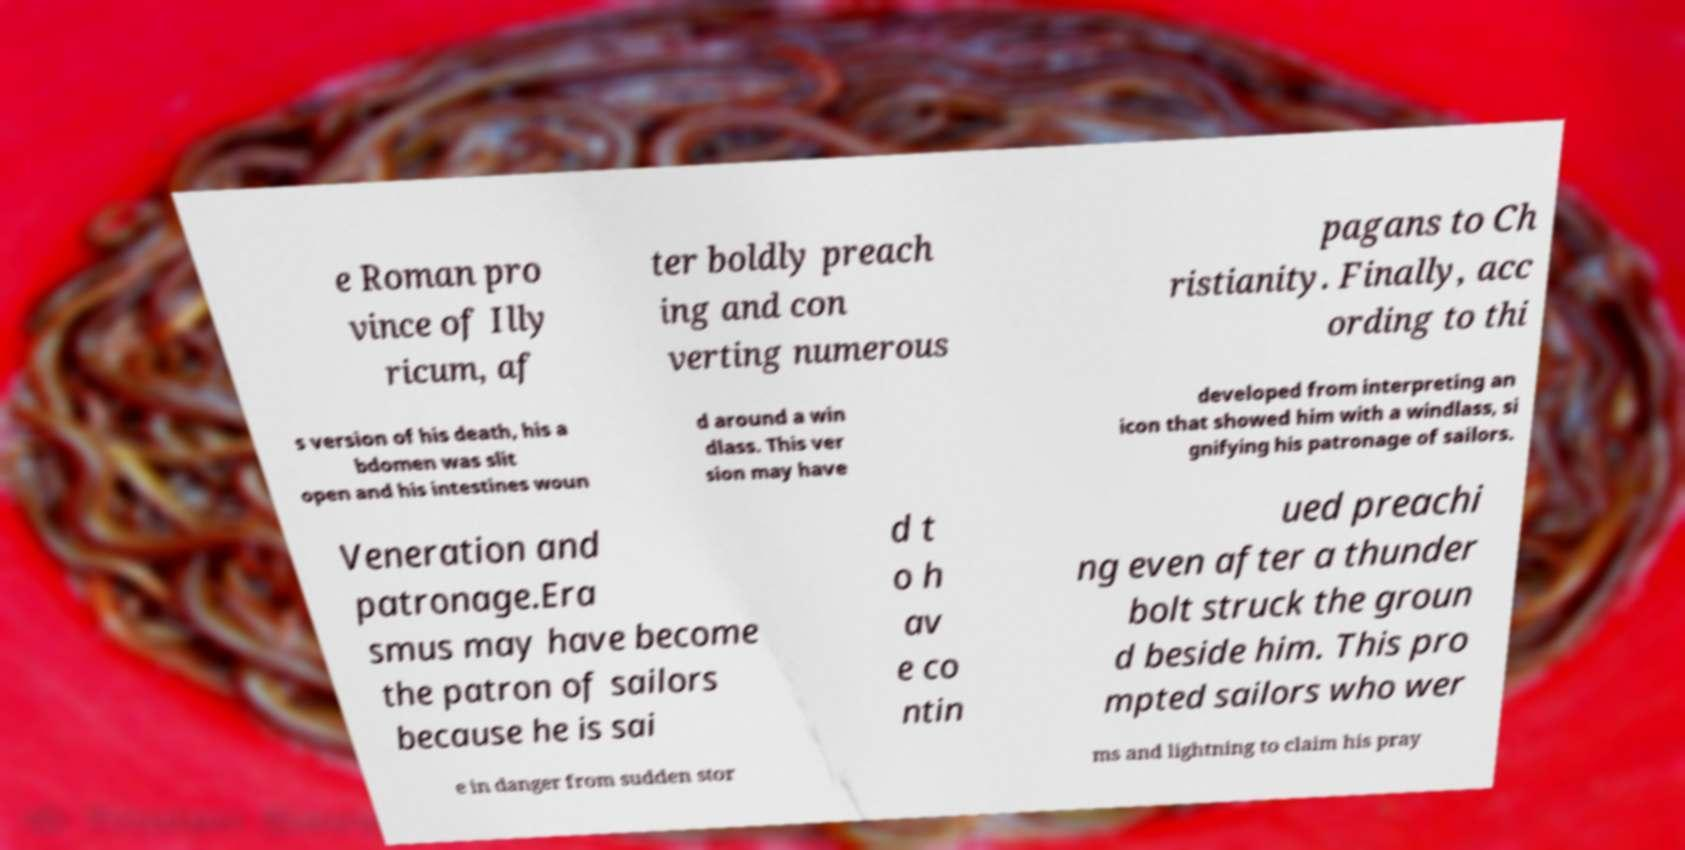Could you assist in decoding the text presented in this image and type it out clearly? e Roman pro vince of Illy ricum, af ter boldly preach ing and con verting numerous pagans to Ch ristianity. Finally, acc ording to thi s version of his death, his a bdomen was slit open and his intestines woun d around a win dlass. This ver sion may have developed from interpreting an icon that showed him with a windlass, si gnifying his patronage of sailors. Veneration and patronage.Era smus may have become the patron of sailors because he is sai d t o h av e co ntin ued preachi ng even after a thunder bolt struck the groun d beside him. This pro mpted sailors who wer e in danger from sudden stor ms and lightning to claim his pray 